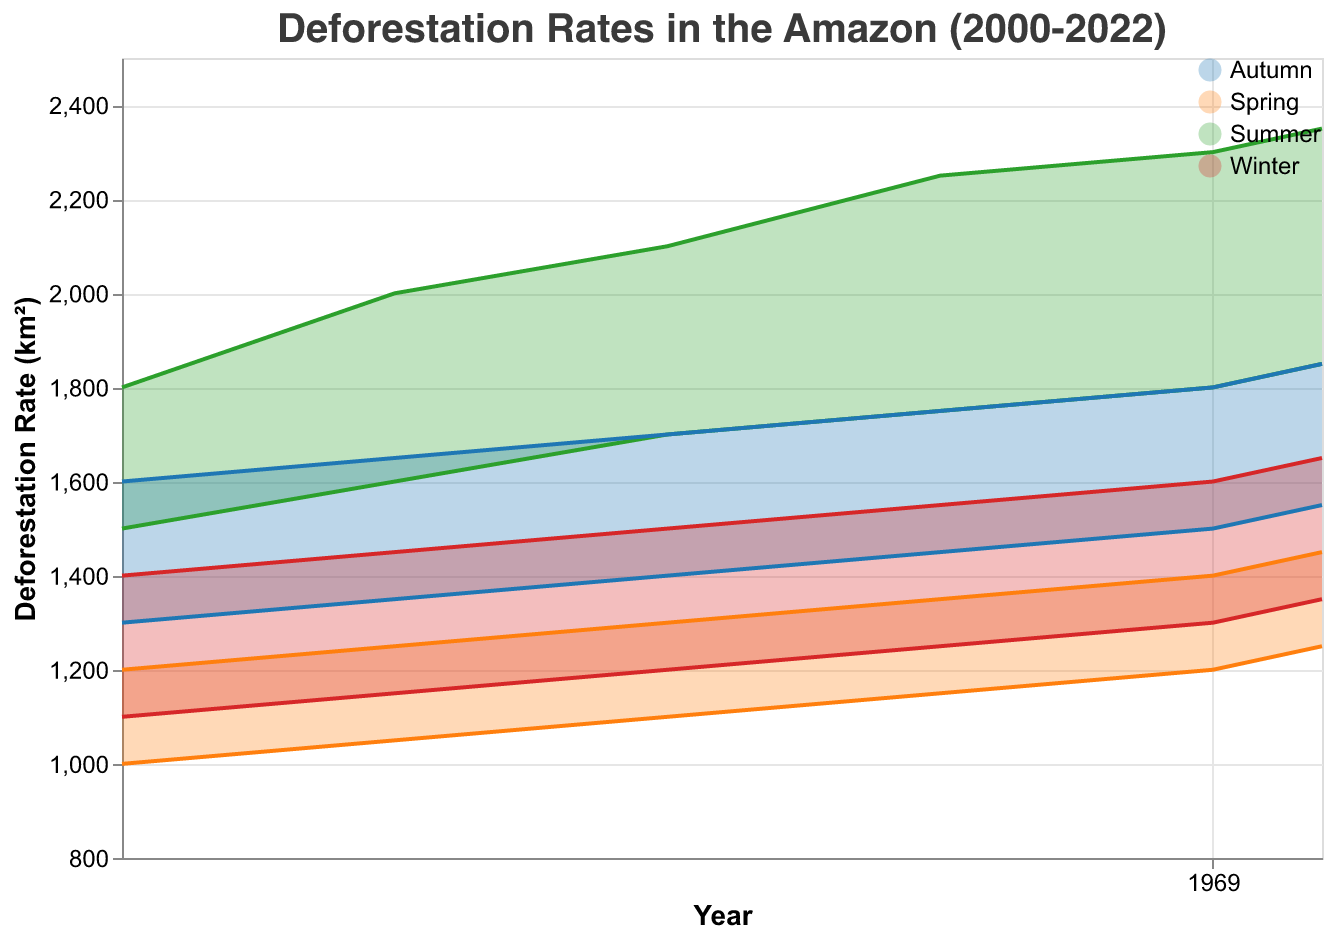What is the title of the figure? The title is generally placed at the top or center of the figure and written in large, bold font. In this case, the title is "Deforestation Rates in the Amazon (2000-2022)" as specified in the code.
Answer: Deforestation Rates in the Amazon (2000-2022) Which season had the highest maximum deforestation rate in 2022? To find the highest maximum deforestation rate in 2022, review the maximum rates for each season in that year. In 2022, Summer had the highest maximum deforestation rate with 2350 km².
Answer: Summer What is the range of deforestation rates in Autumn 2010? The range of deforestation rates can be determined by subtracting the minimum rate from the maximum rate for Autumn 2010. The maximum rate is 1700 km², and the minimum rate is 1400 km². Therefore, the range is 1700 - 1400 = 300 km².
Answer: 300 km² In which year did Spring have the minimum deforestation rate of 1250 km²? To find the necessary year, we look for the minimum deforestation rate of 1250 km² under Spring in the provided data. In this case, it corresponds to the year 2022.
Answer: 2022 How has the maximum deforestation rate in Summer changed from 2000 to 2022? To determine the change, subtract the maximum rate in 2000 from the maximum rate in 2022 for Summer. The rate in 2000 was 1800 km², and it was 2350 km² in 2022. The change is 2350 - 1800 = 550 km².
Answer: 550 km² Which season shows the smallest variation in the maximum deforestation rates across the entire period (2000-2022)? To find the smallest variation, calculate the range (difference between the highest and lowest values) for the maximum deforestation rates of each season across the years. Winter has maximum rates ranging from 1400 km² to 1650 km², a variation of 250 km², which is smaller compared to other seasons.
Answer: Winter What is the overall trend in the minimum deforestation rate in Spring from 2000 to 2022? Observing the progression of minimum deforestation rates in Spring from 2000 to 2022 shows consistent increases: 1000 km² (2000), 1050 km² (2005), 1100 km² (2010), 1150 km² (2015), 1200 km² (2020), 1250 km² (2022). This indicates an upward trend.
Answer: Upward trend Compare the maximum deforestation rates in Summer vs. Winter for the year 2015. Which one is higher, and by how much? In 2015, the maximum deforestation rate in Summer is 2250 km², while for Winter it is 1550 km². To determine the difference, subtract the Winter rate from the Summer rate: 2250 - 1550 = 700 km². Summer's rate is higher.
Answer: Summer by 700 km² What was the minimum deforestation rate in Winter 2005, and how does it compare to Winter 2022? For Winter 2005, the minimum deforestation rate was 1150 km², while for Winter 2022, it was 1350 km². To compare, subtract the 2005 value from the 2022 value: 1350 - 1150 = 200 km². Therefore, Winter 2022 had a 200 km² higher rate.
Answer: Winter 2005: 1150 km², Winter 2022: 200 km² higher Which year recorded the highest deforestation rate for any season, and what was the value? Reviewing the maximum deforestation rates across all years and seasons, the highest was 2350 km² in Summer 2022.
Answer: 2022, 2350 km² 